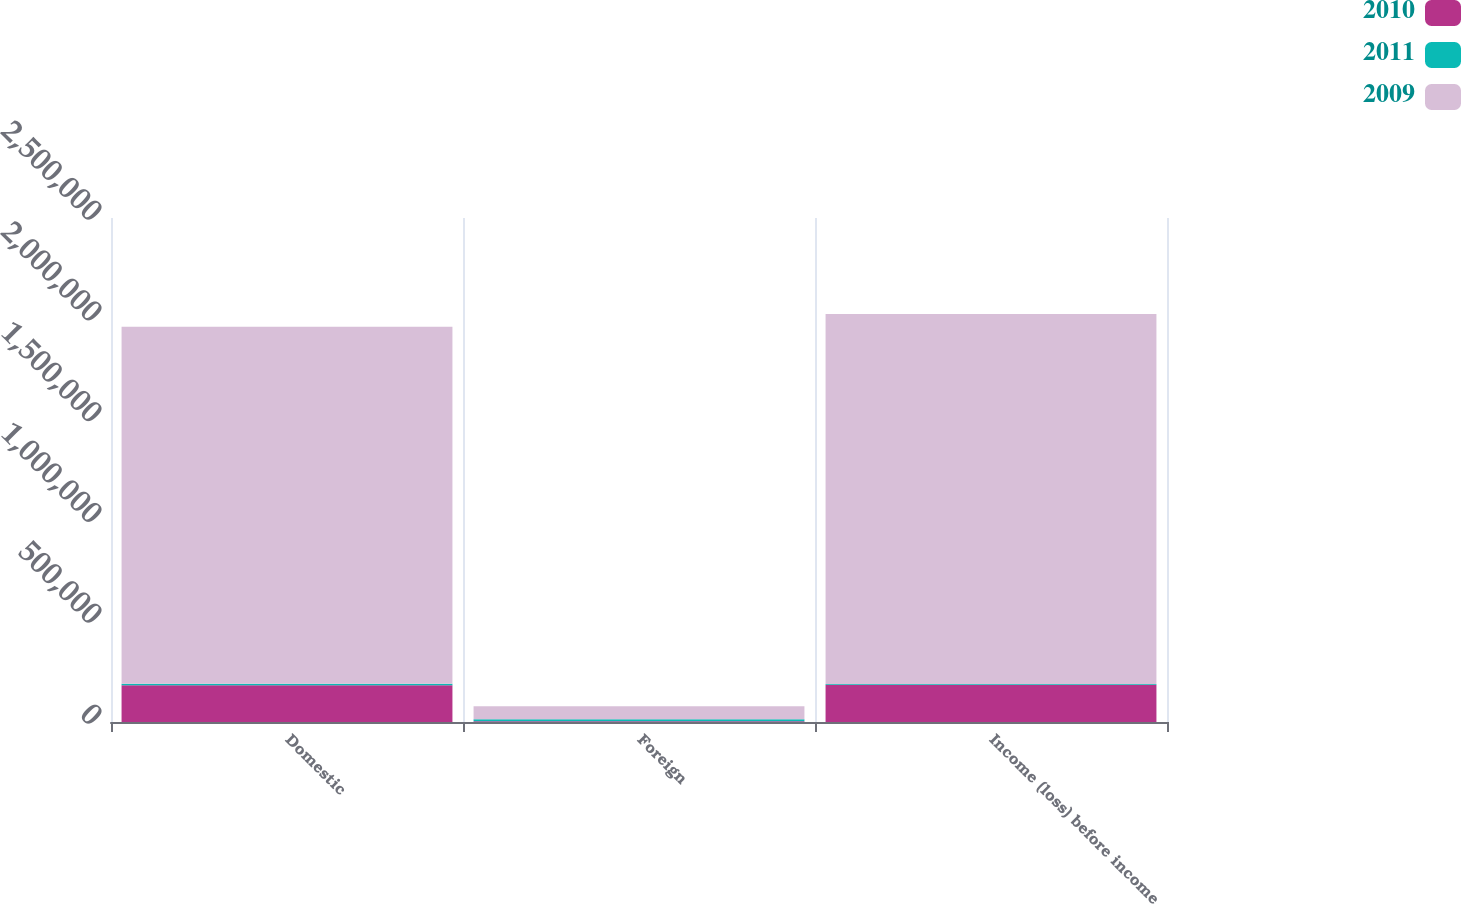<chart> <loc_0><loc_0><loc_500><loc_500><stacked_bar_chart><ecel><fcel>Domestic<fcel>Foreign<fcel>Income (loss) before income<nl><fcel>2010<fcel>181959<fcel>3371<fcel>185330<nl><fcel>2011<fcel>7426<fcel>10567<fcel>3141<nl><fcel>2009<fcel>1.77169e+06<fcel>63738<fcel>1.83543e+06<nl></chart> 